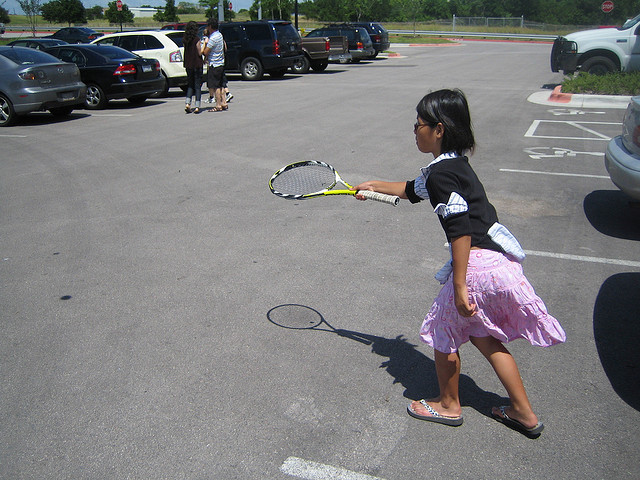<image>Who is the lady? I don't know who the lady is. She could be a girl, a tennis player, or a mother. Who is the lady? I don't know who the lady is. It could be a girl, a tennis player, or someone's mother. 